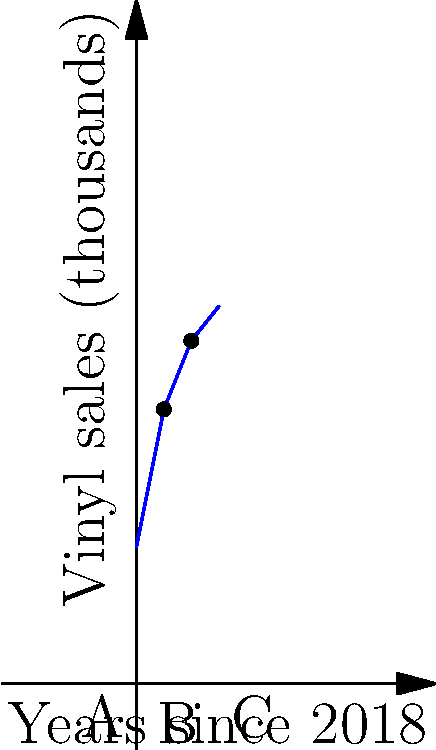A vintage record store in Toronto tracks its vinyl sales over time. The graph shows the number of vinyl records sold (in thousands) since 2018, represented by a piecewise function. At which point does the rate of change in vinyl sales most closely reflect the surge in indie music popularity you experienced while living in Toronto? To answer this question, we need to analyze the rate of change (slope) in each segment of the piecewise function:

1. Segment A (0 ≤ x < 2):
   The slope is steepest here, representing the fastest growth.
   Rate of change = $\frac{20 - 10}{2 - 0} = 5$ thousand records per year

2. Segment B (2 ≤ x < 4):
   The slope decreases, indicating slower growth.
   Rate of change = $\frac{25 - 20}{4 - 2} = 2.5$ thousand records per year

3. Segment C (4 ≤ x ≤ 6):
   The slope is the least steep, showing the slowest growth.
   Rate of change = $\frac{27.5 - 25}{6 - 4} = 1.25$ thousand records per year

The steepest slope in Segment A (0 ≤ x < 2) represents the highest rate of change, which would most closely reflect a surge in indie music popularity. This rapid growth in vinyl sales aligns with the nostalgic feelings of a former Toronto resident who experienced the thriving local music scene.
Answer: Segment A (0 ≤ x < 2) 